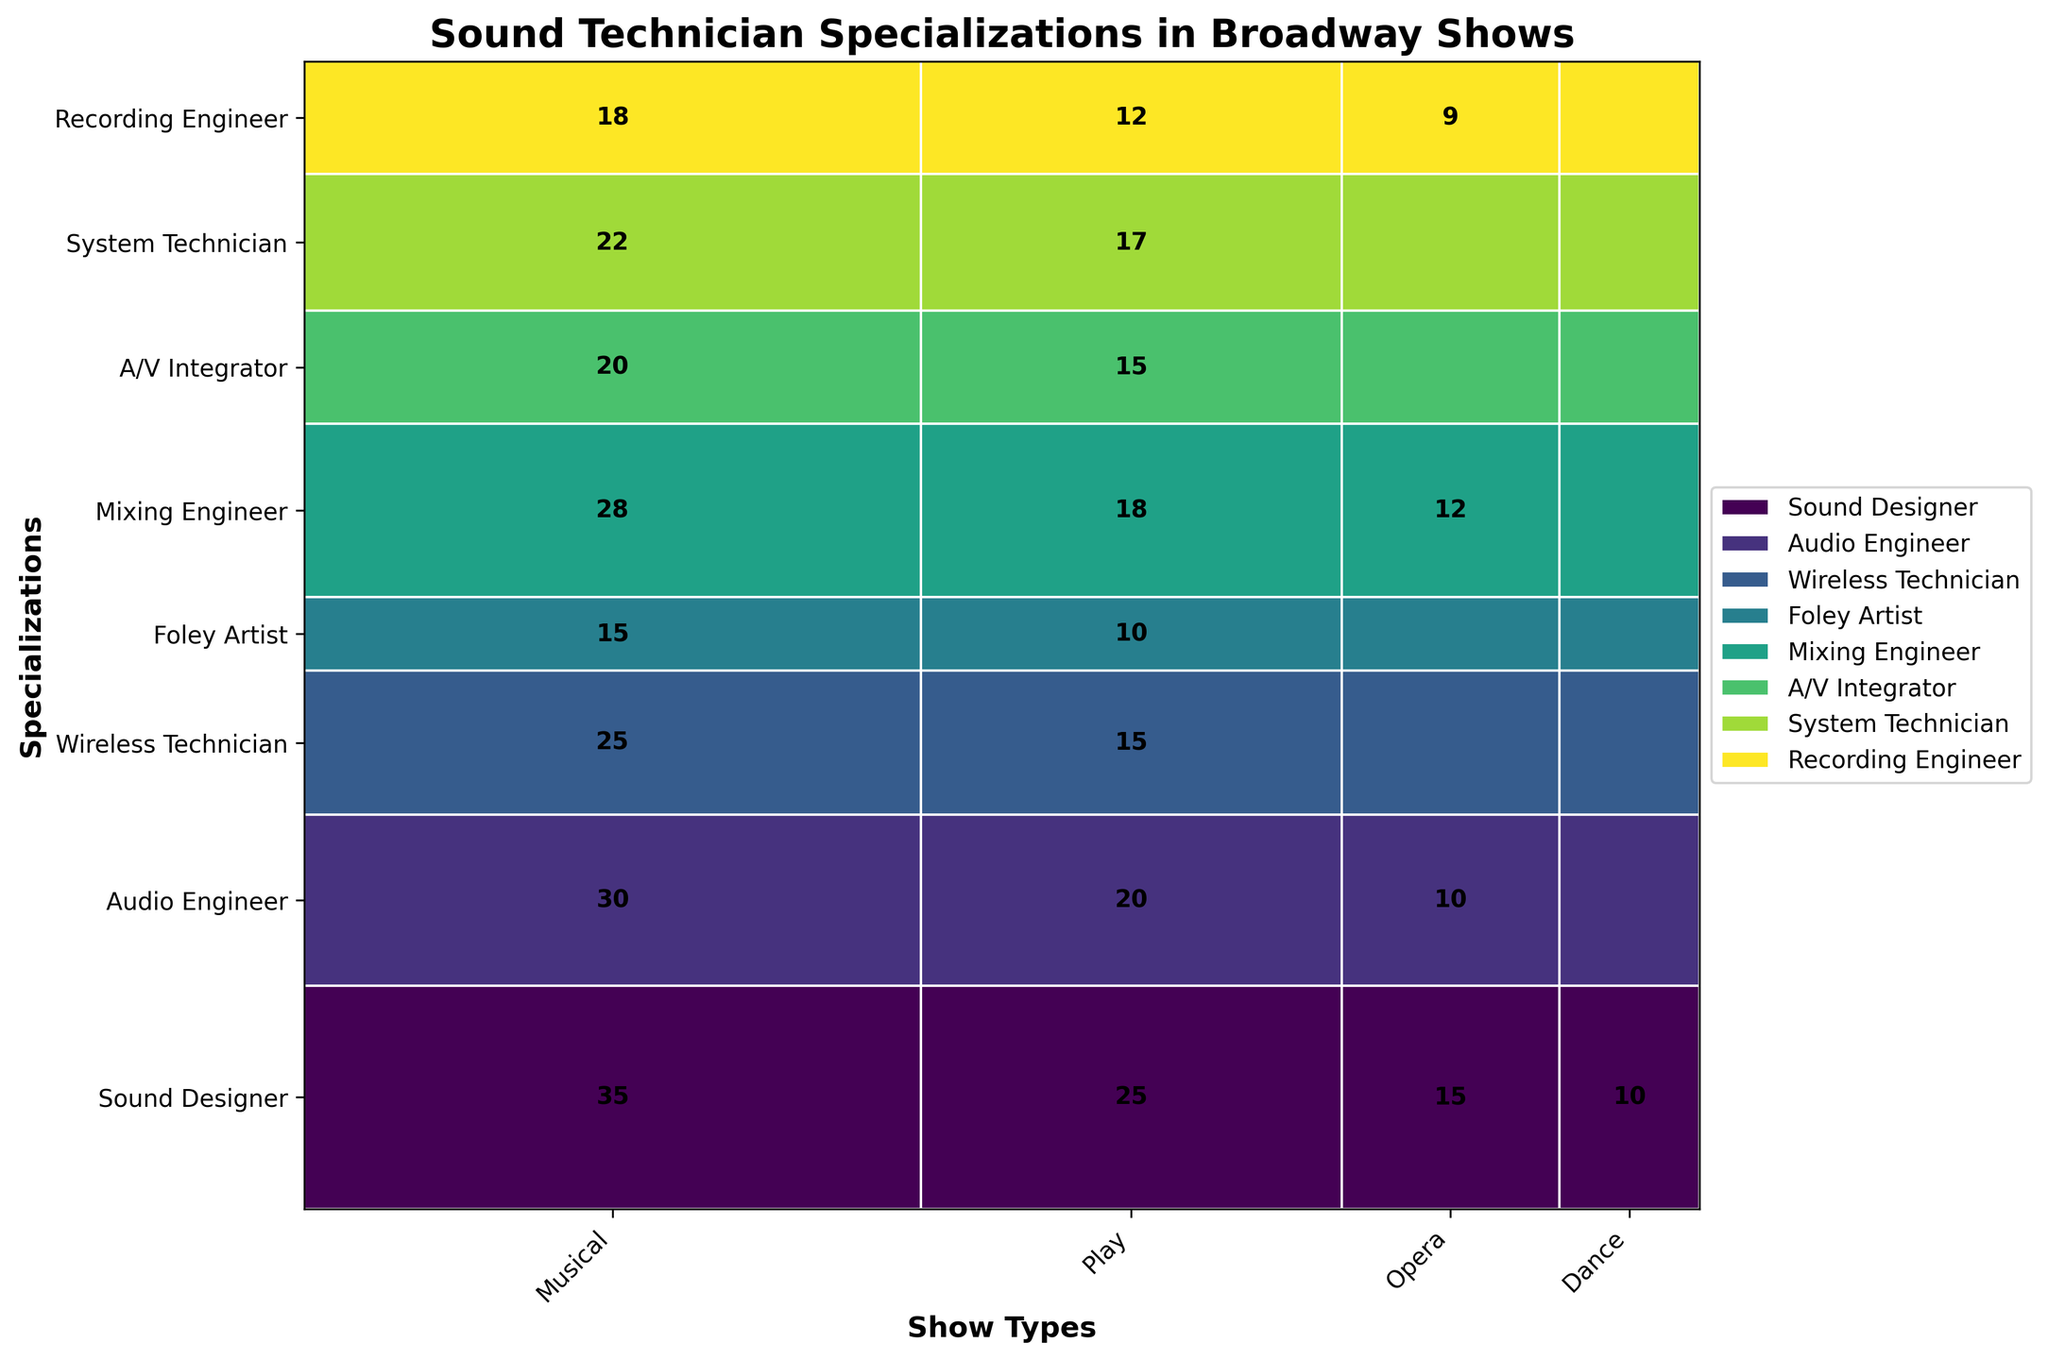What is the title of the figure? The title of the figure is located at the top and clearly indicated.
Answer: Sound Technician Specializations in Broadway Shows Which specialization has the highest count in Musicals? By examining the widths of the rectangles in the "Musical" column, the Sound Designer rectangle is the largest.
Answer: Sound Designer Which Show type has the highest number of Wireless Technicians? By comparing the heights of the Wireless Technician rectangles, "Musical" has the tallest one.
Answer: Musical How many specializations have counts in plays? By counting the number of specializations listed along the y-axis, all specializations are present in plays.
Answer: 8 What is the total number of A/V Integrators? Sum the values of A/V Integrators across all show types (20 + 15 + 5 + 3).
Answer: 43 Which specialization has the smallest proportion in Operas? The smallest rectangle in the "Opera" column is for Foley Artists.
Answer: Foley Artist Is the proportion of Audio Engineers in Musicals greater than that in Plays? Compare the heights of the Audio Engineer rectangles in the "Musical" and "Play" columns. The Musical rectangle is taller.
Answer: Yes What specialization represents the largest proportion of sound technicians for Dance shows? The tallest rectangle in the "Dance" column represents Mixing Engineers.
Answer: Mixing Engineer What is the combined count of Sound Designers and Mixing Engineers in Plays? Add the values for Sound Designers (25) and Mixing Engineers (18) in Plays.
Answer: 43 